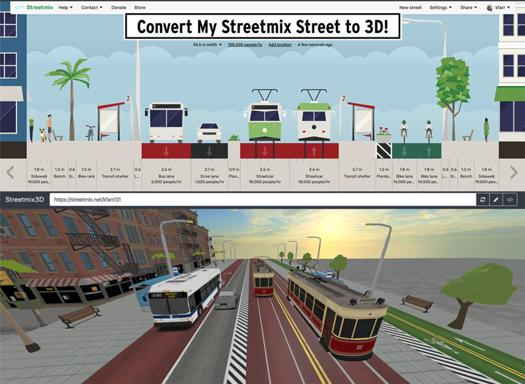What specific elements can be controlled and adjusted in the Streetmix interface? Users can adjust a variety of elements within the Streetmix interface, including road width, the type of transportation lanes (bike, car, tram), sidewalk width, and the addition of urban furniture like benches and trees. Each element can be tailored to match specific urban layouts and design requirements. 